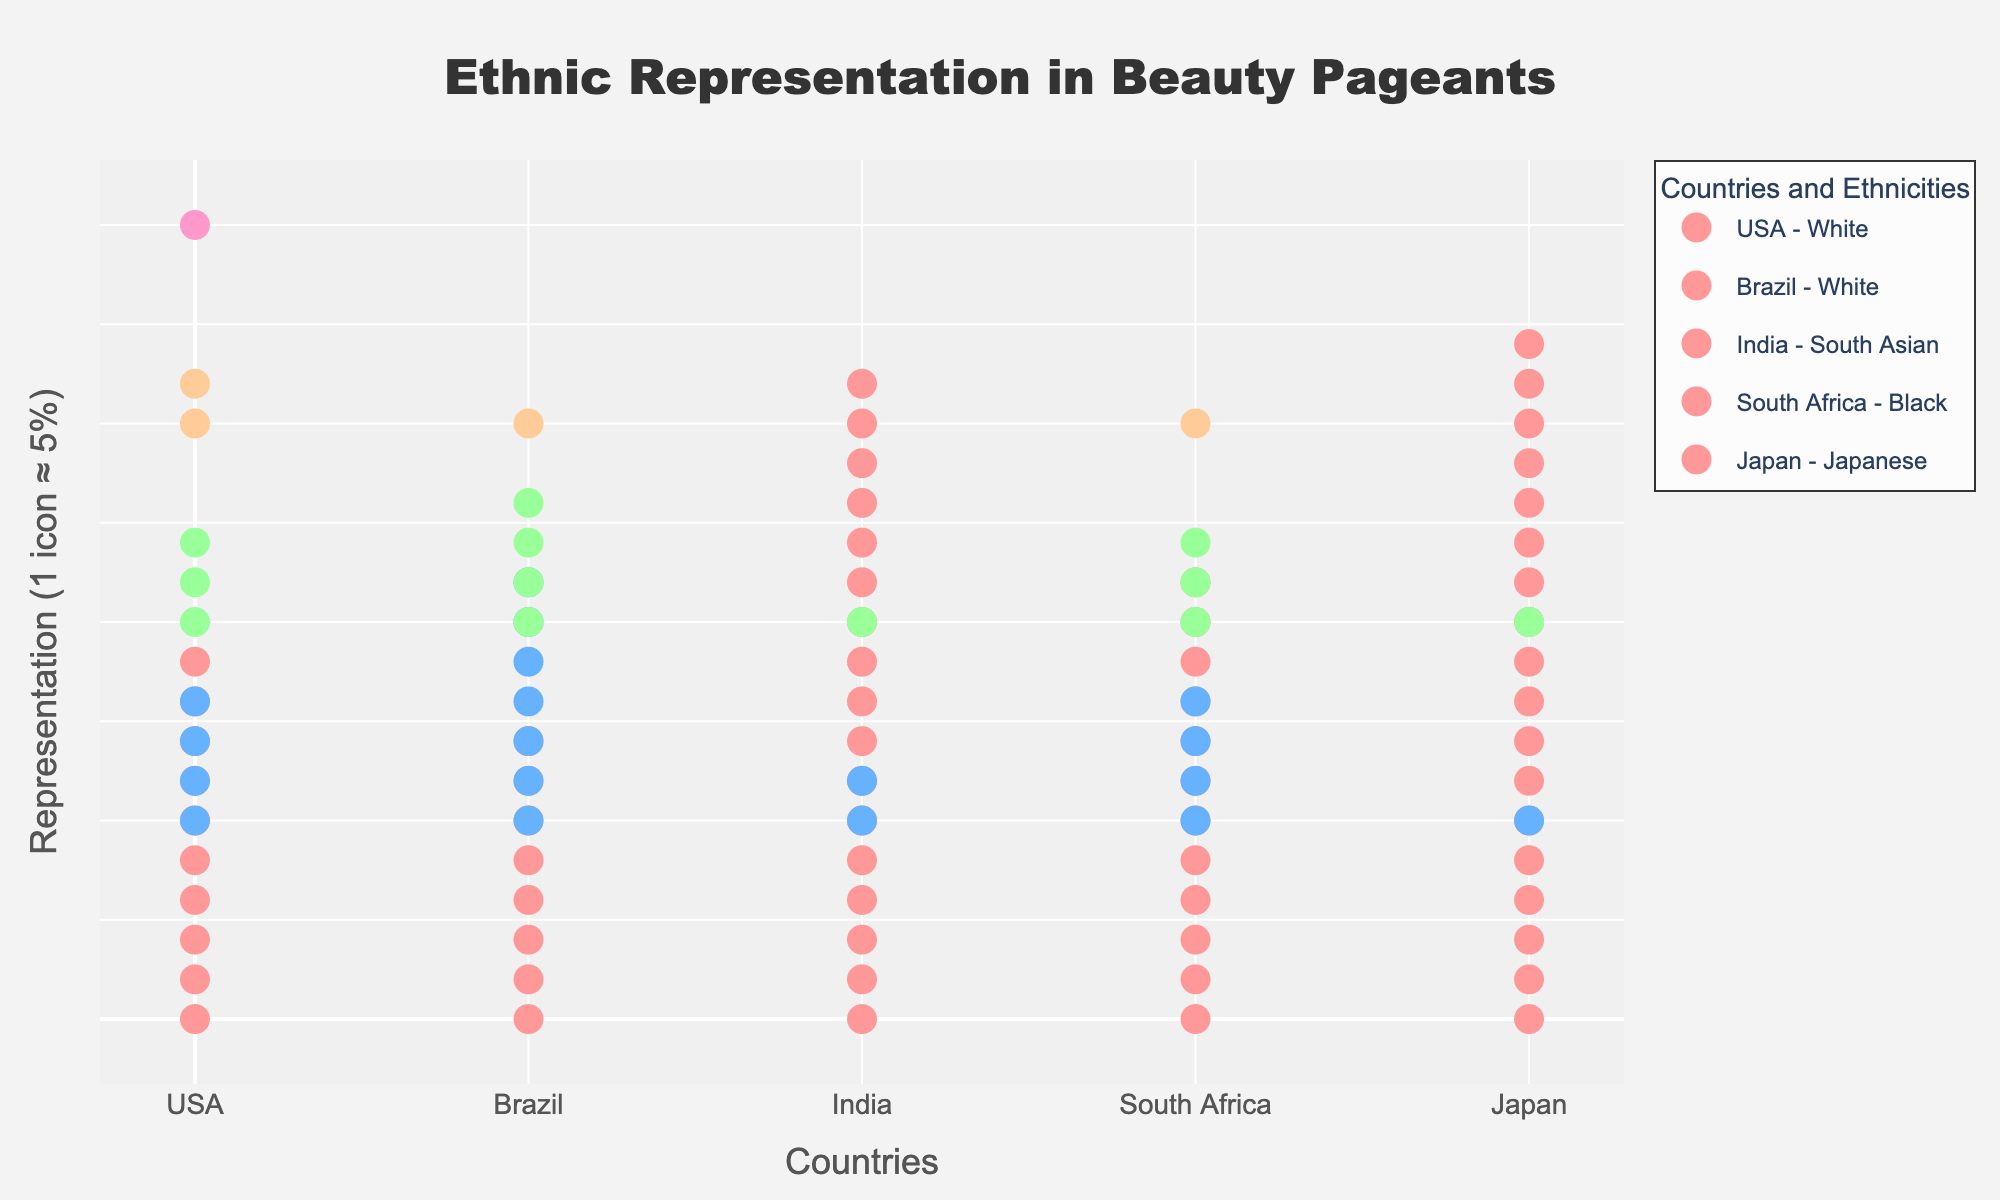What is the title of the figure? The title of the figure is displayed at the top. It reads "Ethnic Representation in Beauty Pageants."
Answer: Ethnic Representation in Beauty Pageants How many countries are represented in the plot? The figure has ticks with country names along the x-axis. By counting these ticks, we see that there are 5 countries represented.
Answer: 5 Which ethnic group dominates the representation in Japan? Japan has multiple circles representing various ethnicities. The cluster with the most numerous circles belongs to the Japanese ethnicity.
Answer: Japanese How many total ethnicities are represented in the USA? In the USA section, each group of circles represents a different ethnicity. Counting all distinct labels provided for the USA reveals there are 5 ethnicities.
Answer: 5 What percentage of representation do South Asian ethnicities have in India? By looking at India and the annotations provided with the circle clusters, the South Asian ethnicity has a representation of 85%.
Answer: 85% Which country has the highest representation of mixed ethnicity? Observing each country and their respective annotations, Brazil has a mixed ethnicity group with a representation of 35%, which is the highest among countries.
Answer: Brazil What's the combined representation of Black ethnicity in both the USA and Brazil? In the USA, the Black ethnicity has a 20% representation; in Brazil, it is 20%. Adding these gives 20% + 20% = 40%.
Answer: 40% Which country shows the most diversity in ethnic representation? By counting the number of different ethnic groups per country, we see that the USA has 5 ethnicities, Brazil has 4, India 3, South Africa 4, and Japan 3. The USA has the most diversity with 5 ethnicities.
Answer: USA How does the representation of White ethnicity in Brazil compare to the USA? The annotations indicate that White ethnicity in Brazil is 40%, while in the USA it is 50%. Thus, the representation in Brazil is 10% lower than in the USA.
Answer: 10% lower What is the color used to represent the Other ethnicity in Japan? Observing the color coding for the "Other" ethnicity in Japan, it is represented by a light color that matches a particular legend entry. This color is a light yellow or pale color in the plot.
Answer: Light yellow 